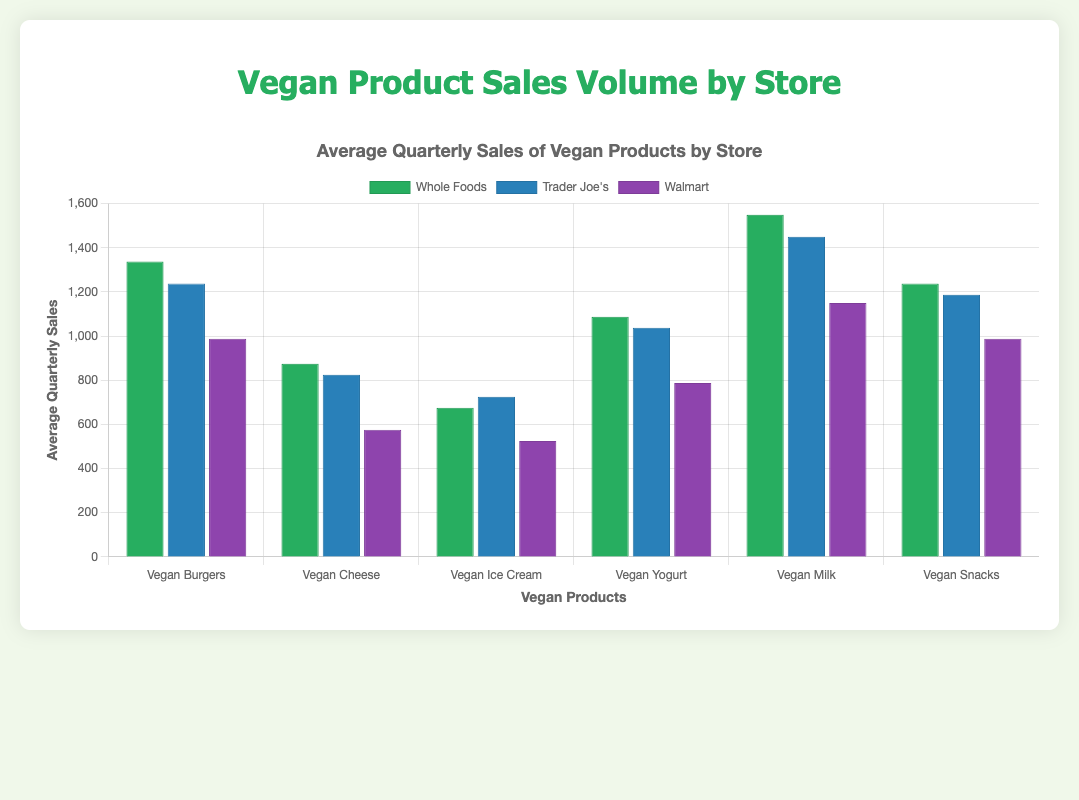Which store has the highest average quarterly sales for Vegan Burgers? Look at the heights of the bars representing average sales for Vegan Burgers. Whole Foods has the tallest bar for this product, indicating the highest average quarterly sales.
Answer: Whole Foods Which product has the lowest average quarterly sales at Walmart? Compare the heights of the bars for different products at Walmart. Vegan Ice Cream has the shortest bar, indicating the lowest average quarterly sales.
Answer: Vegan Ice Cream What is the difference in average quarterly sales of Vegan Milk between Whole Foods and Trader Joe's? Calculate the difference by subtracting Trader Joe's average quarterly sales of Vegan Milk from Whole Food's. Whole Foods has an average of 1550 and Trader Joe's has 1450, so 1550 - 1450.
Answer: 100 Which store's average quarterly sales for Vegan Snacks is closest to 1250? Look at the heights of the bars representing the average sales for Vegan Snacks. Trader Joe's has an average closest to 1250, with a value of 1187.5.
Answer: Trader Joe's How does the average quarterly sales of Vegan Yogurt at Trader Joe's compare to Whole Foods? Compare the heights of the bars for Vegan Yogurt at Trader Joe's and Whole Foods. Trader Joe's average is slightly lower than Whole Foods.
Answer: Lower Combine the average quarterly sales of Vegan Cheese and Vegan Ice Cream at Walmart. Find the average sales of each (Vegan Cheese: 625, Vegan Ice Cream: 525) and sum them: 625 + 525.
Answer: 1150 What percentage of the quarterly sales of Vegan Milk at Whole Foods is compared to Trader Joe's? Divide Whole Foods' average quarterly sales by Trader Joe's and multiply by 100. (1550 / 1450) * 100.
Answer: 106.9% Which product shows the most significant increase in average sales from Q1 to Q4 in Whole Foods? Calculate the increase for each product from Q1 to Q4 and find the most significant. Vegan Milk increases by 300 units.
Answer: Vegan Milk What is the ratio of average quarterly sales of Vegan Ice Cream at Whole Foods to Vegan Burgers at Walmart? Divide Whole Foods' average sales of Vegan Ice Cream (675) by Walmart's Vegan Burgers (987.5).
Answer: 0.684 Sum the average quarterly sales of all products at Trader Joe's. Add the average quarterly sales of all products (1187.5 + 825 + 725 + 1037.5 + 1450 + 1187.5).
Answer: 6412.5 